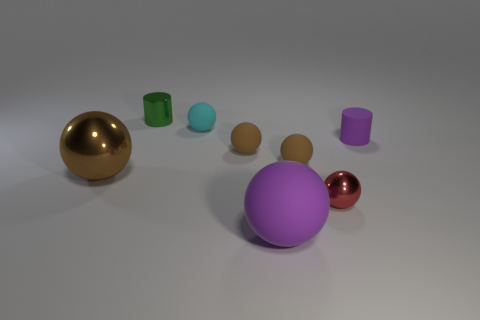How many brown spheres must be subtracted to get 1 brown spheres? 2 Subtract all red shiny balls. How many balls are left? 5 Subtract all gray cylinders. How many brown spheres are left? 3 Subtract all red balls. How many balls are left? 5 Subtract 3 balls. How many balls are left? 3 Add 1 green objects. How many objects exist? 9 Subtract 0 blue cylinders. How many objects are left? 8 Subtract all spheres. How many objects are left? 2 Subtract all cyan balls. Subtract all blue cubes. How many balls are left? 5 Subtract all balls. Subtract all cyan matte things. How many objects are left? 1 